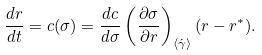<formula> <loc_0><loc_0><loc_500><loc_500>\frac { d r } { d t } = c ( \sigma ) = \frac { d c } { d \sigma } \left ( \frac { \partial \sigma } { \partial r } \right ) _ { \langle \dot { \gamma } \rangle } ( r - r ^ { * } ) .</formula> 